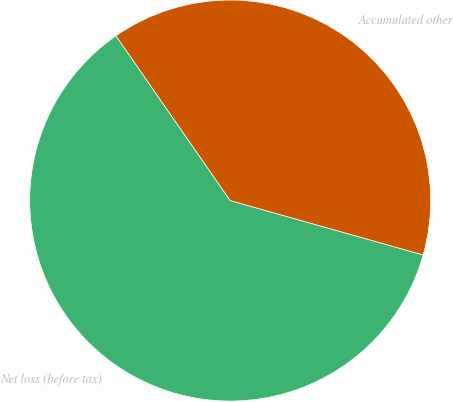<chart> <loc_0><loc_0><loc_500><loc_500><pie_chart><fcel>Net loss (before tax)<fcel>Accumulated other<nl><fcel>60.98%<fcel>39.02%<nl></chart> 